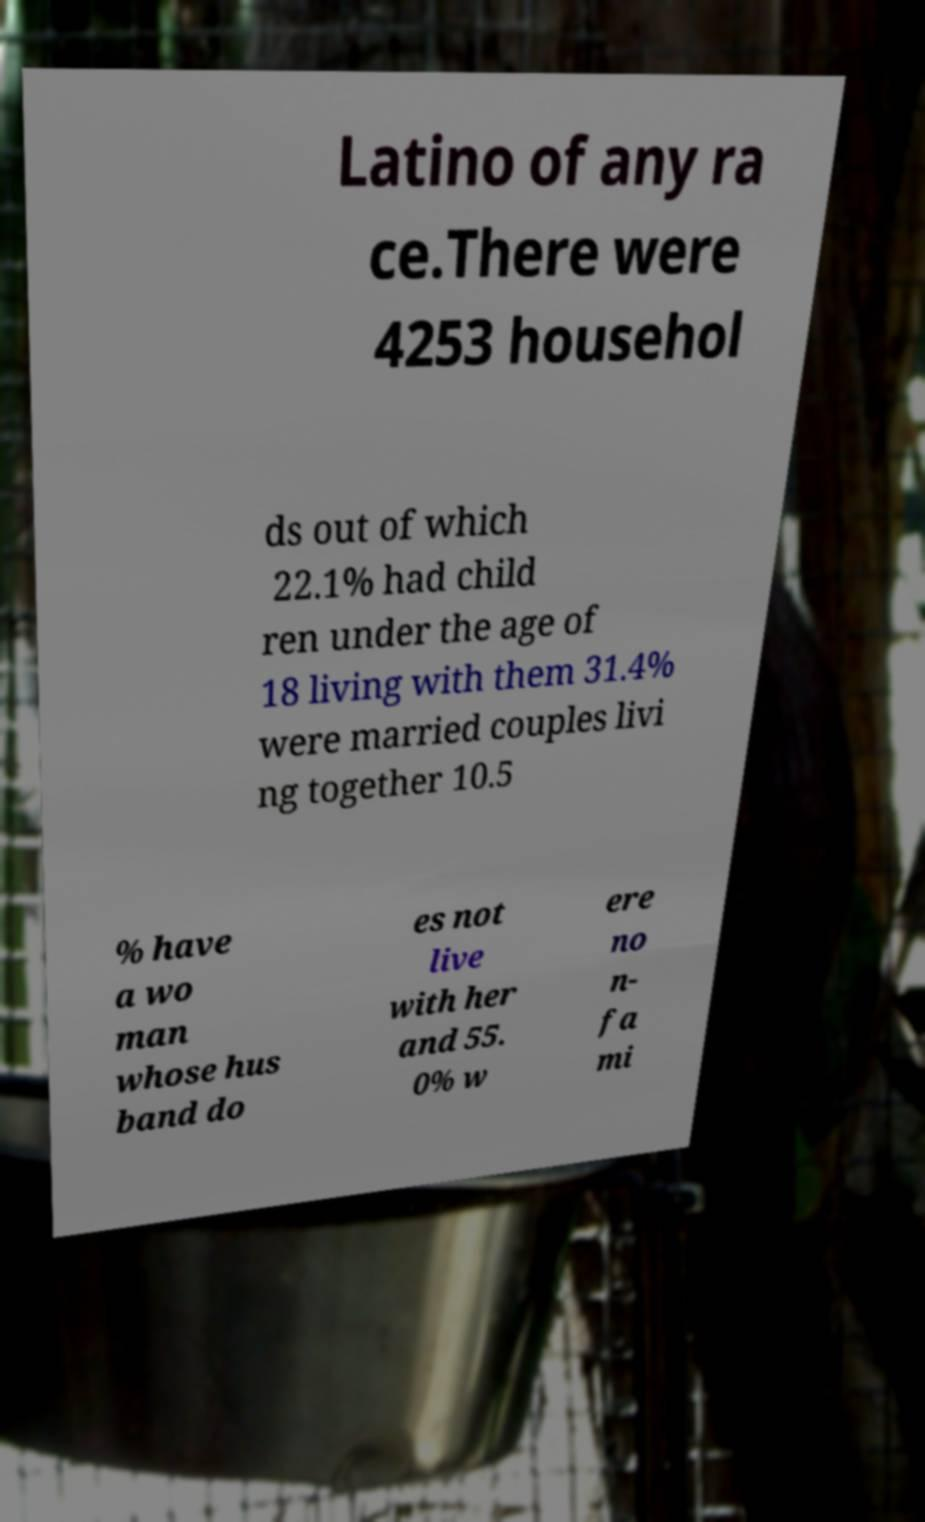Please identify and transcribe the text found in this image. Latino of any ra ce.There were 4253 househol ds out of which 22.1% had child ren under the age of 18 living with them 31.4% were married couples livi ng together 10.5 % have a wo man whose hus band do es not live with her and 55. 0% w ere no n- fa mi 